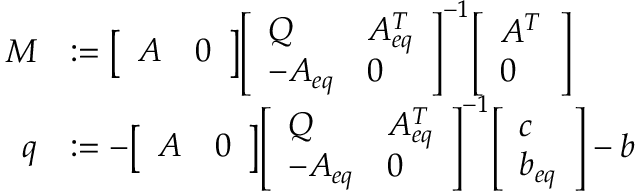Convert formula to latex. <formula><loc_0><loc_0><loc_500><loc_500>{ \begin{array} { r l } { M } & { \colon = { \left [ \begin{array} { l l } { A } & { 0 } \end{array} \right ] } { \left [ \begin{array} { l l } { Q } & { A _ { e q } ^ { T } } \\ { - A _ { e q } } & { 0 } \end{array} \right ] } ^ { - 1 } { \left [ \begin{array} { l } { A ^ { T } } \\ { 0 } \end{array} \right ] } } \\ { q } & { \colon = - { \left [ \begin{array} { l l } { A } & { 0 } \end{array} \right ] } { \left [ \begin{array} { l l } { Q } & { A _ { e q } ^ { T } } \\ { - A _ { e q } } & { 0 } \end{array} \right ] } ^ { - 1 } { \left [ \begin{array} { l } { c } \\ { b _ { e q } } \end{array} \right ] } - b } \end{array} }</formula> 